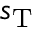Convert formula to latex. <formula><loc_0><loc_0><loc_500><loc_500>s _ { T }</formula> 